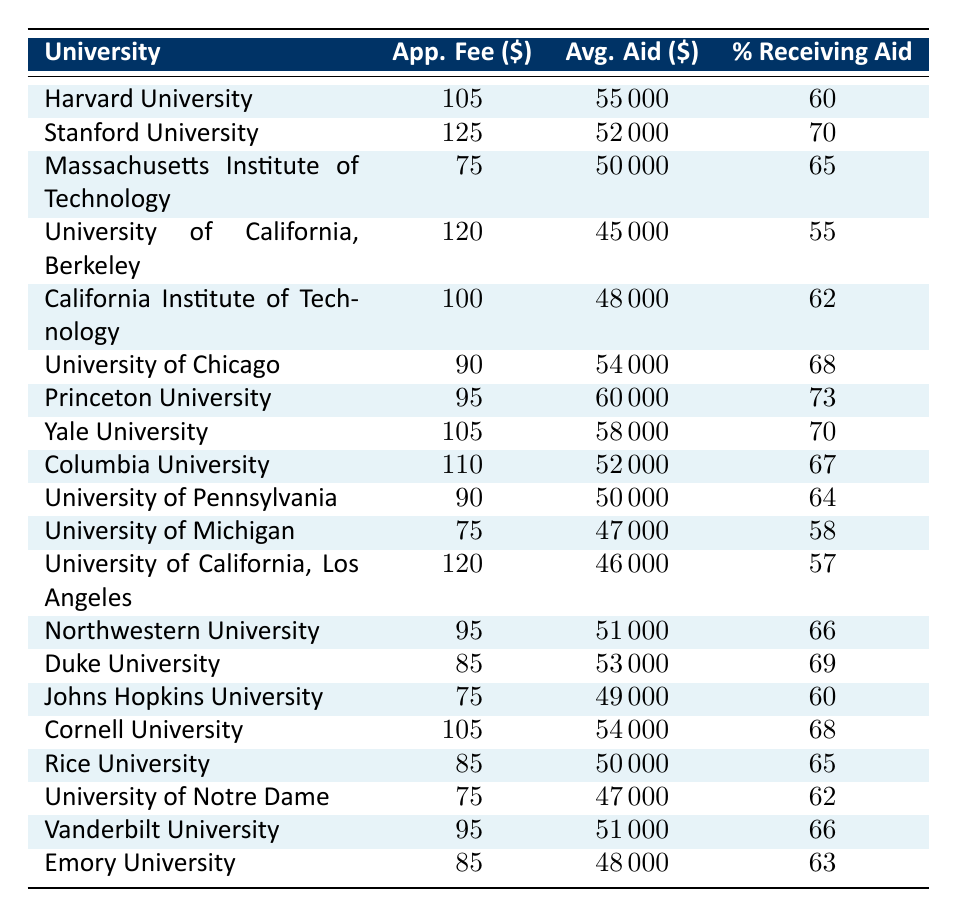What is the highest application fee among these universities? The table lists the application fees for each university, and by examining the values, the highest application fee is for Stanford University, which is 125 dollars.
Answer: 125 Which university has the largest average financial aid package? The average financial aid packages are provided for each university, and the largest package is offered by Princeton University, which is 60000 dollars.
Answer: 60000 What percentage of students at the University of California, Berkeley receive financial aid? The table specifically states the percentage of students receiving financial aid at the University of California, Berkeley, which is 55 percent.
Answer: 55 Is the average financial aid package at Yale University higher than the average at the University of Michigan? Comparing the average financial aid packages, Yale University has 58000 dollars while the University of Michigan has 47000 dollars. Since 58000 is greater than 47000, the statement is true.
Answer: Yes What is the average application fee for the universities that have more than 60% of students receiving financial aid? To find the average fee, we first identify universities with over 60%: Stanford (125), MIT (75), Chicago (90), Princeton (95), Yale (105), Northwestern (95), Duke (85), Cornell (105), and Vanderbilt (95). Their fees sum up to (125 + 75 + 90 + 95 + 105 + 95 + 85 + 105 + 95) = 1,065 dollars. There are 9 universities, so the average is 1,065 / 9 = approximately 118.33.
Answer: 118.33 What is the difference in average financial aid between Harvard University and California Institute of Technology? Harvard offers an average financial aid package of 55000 dollars and California Institute of Technology offers 48000 dollars. The difference between these two amounts is calculated as 55000 - 48000 = 7000 dollars.
Answer: 7000 At which university does a higher percentage of students receive financial aid: Johns Hopkins University or Emory University? According to the table, 60% of students at Johns Hopkins University receive financial aid, while Emory University has 63%. Since 63% is greater than 60%, Emory University has the higher percentage.
Answer: Emory University Which university has an application fee of 85 dollars? By reviewing the application fee amounts in the table, we see that both Duke University and Rice University have an application fee of 85 dollars.
Answer: Duke University and Rice University How many universities have an average financial aid package less than 50000 dollars? The table lists average financial aid packages, and those below 50000 dollars are: UC Berkeley (45000), California Institute of Technology (48000), University of Michigan (47000), University of California, Los Angeles (46000), and University of Notre Dame (47000). Five universities fall into this category.
Answer: 5 